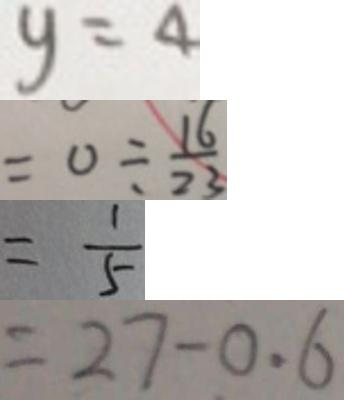Convert formula to latex. <formula><loc_0><loc_0><loc_500><loc_500>y = 4 
 = 0 \div \frac { 1 6 } { 2 3 } 
 = \frac { 1 } { 5 } 
 = 2 7 - 0 . 6</formula> 